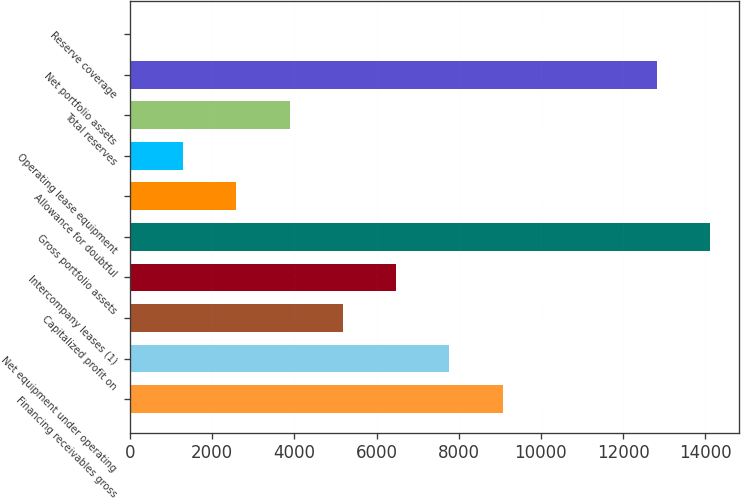<chart> <loc_0><loc_0><loc_500><loc_500><bar_chart><fcel>Financing receivables gross<fcel>Net equipment under operating<fcel>Capitalized profit on<fcel>Intercompany leases (1)<fcel>Gross portfolio assets<fcel>Allowance for doubtful<fcel>Operating lease equipment<fcel>Total reserves<fcel>Net portfolio assets<fcel>Reserve coverage<nl><fcel>9066.7<fcel>7771.6<fcel>5181.4<fcel>6476.5<fcel>14113.1<fcel>2591.2<fcel>1296.1<fcel>3886.3<fcel>12818<fcel>1<nl></chart> 